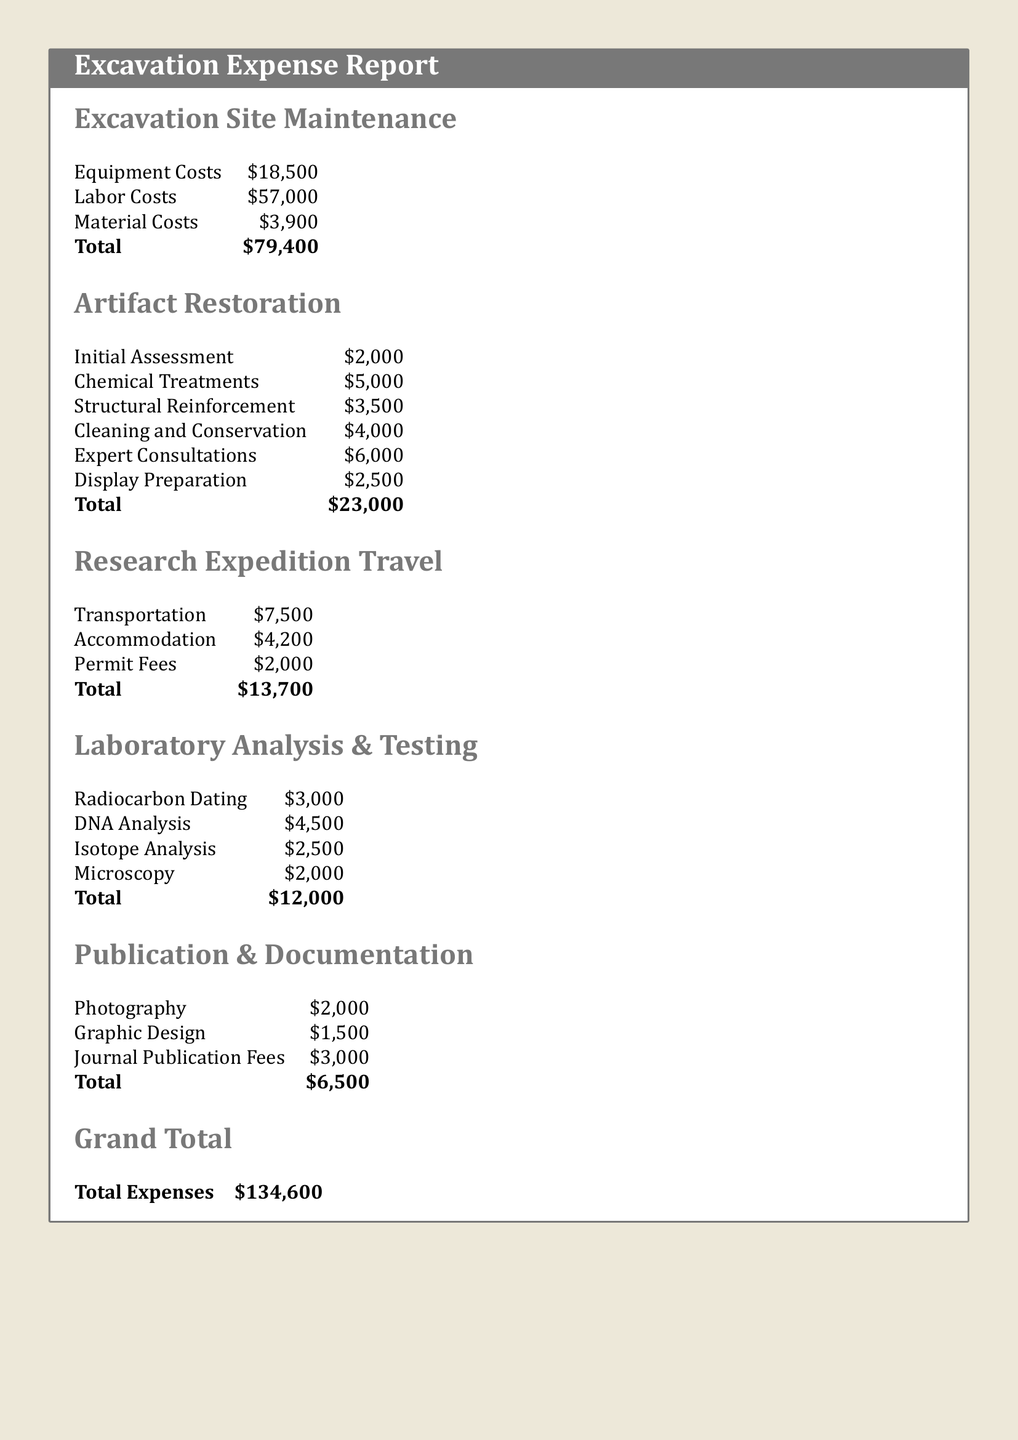what is the total cost of excavation site maintenance? The total cost of excavation site maintenance is provided under the relevant section, which lists the combined expenses for equipment, labor, and materials.
Answer: $79,400 how much was spent on expert consultations in artifact restoration? The costs relating to expert consultations can be found specifically in the artifact restoration section of the report.
Answer: $6,000 what are the total travel expenses for the research expedition? The travel expenses are detailed in the respective section, showing transportation, accommodation, and permit fees summed up.
Answer: $13,700 what is the cost of chemical treatments for artifact restoration? The expenditure for chemical treatments can be located within the detailed costs listed for the restoration process.
Answer: $5,000 how much did the laboratory analysis and testing cost in total? The total for laboratory analysis and testing is calculated by summing all individual testing costs outlined in that section of the document.
Answer: $12,000 what is the amount allocated for publication and documentation fees? Fees related to publication and documentation have their own section, which provides a clear breakdown of these costs.
Answer: $6,500 what is the grand total of all expenses? The grand total represents the cumulative amount of all sections detailed throughout the report.
Answer: $134,600 what is the cost of structural reinforcement in artifact restoration? This specific cost can be found in the artifact restoration section, detailing various expenses associated with the restoration of artifacts.
Answer: $3,500 